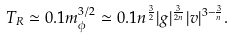Convert formula to latex. <formula><loc_0><loc_0><loc_500><loc_500>T _ { R } \simeq 0 . 1 m _ { \phi } ^ { 3 / 2 } \simeq 0 . 1 n ^ { \frac { 3 } { 2 } } | g | ^ { \frac { 3 } { 2 n } } | v | ^ { 3 - \frac { 3 } { n } } .</formula> 